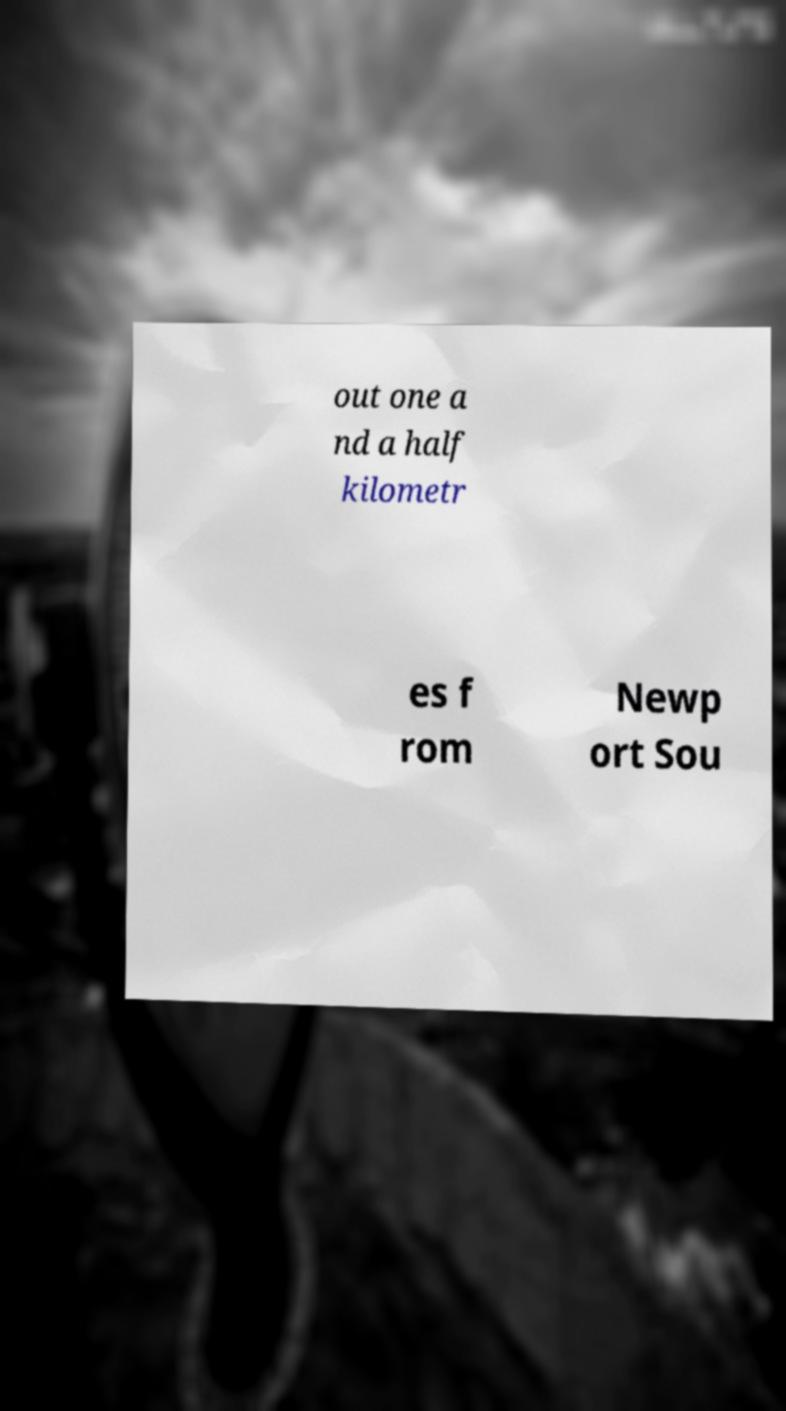I need the written content from this picture converted into text. Can you do that? out one a nd a half kilometr es f rom Newp ort Sou 